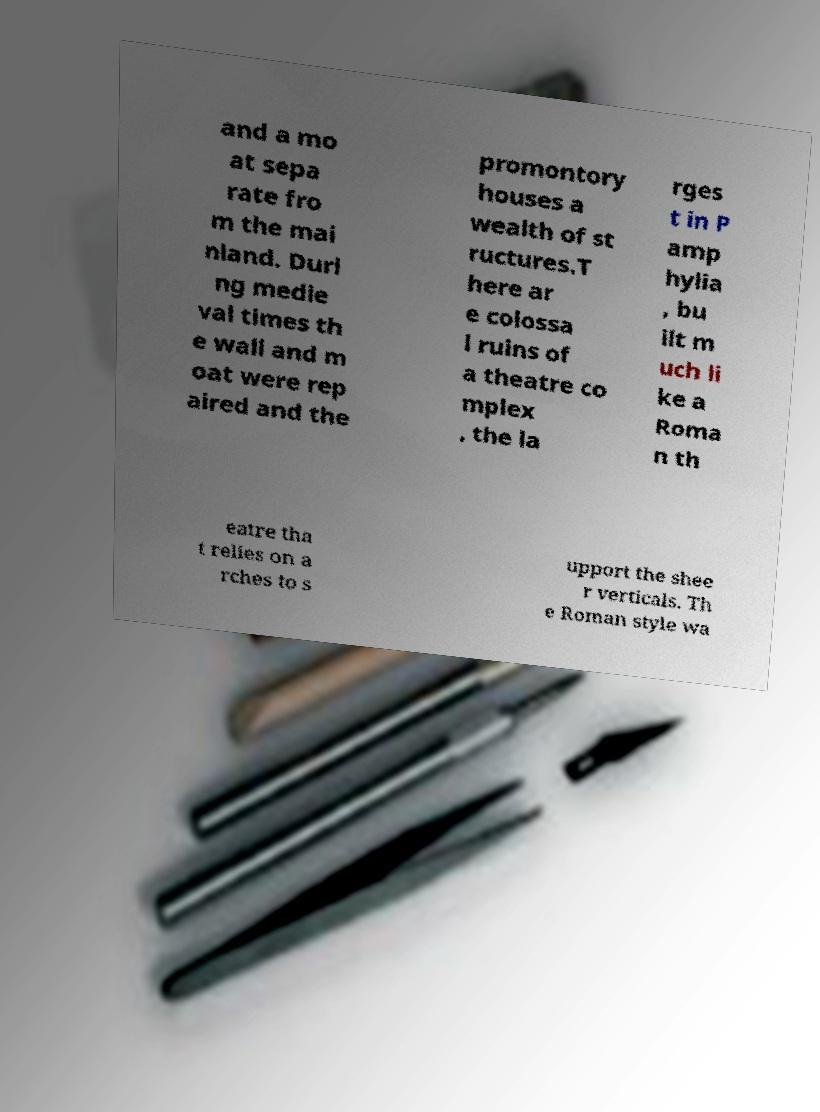There's text embedded in this image that I need extracted. Can you transcribe it verbatim? and a mo at sepa rate fro m the mai nland. Duri ng medie val times th e wall and m oat were rep aired and the promontory houses a wealth of st ructures.T here ar e colossa l ruins of a theatre co mplex , the la rges t in P amp hylia , bu ilt m uch li ke a Roma n th eatre tha t relies on a rches to s upport the shee r verticals. Th e Roman style wa 